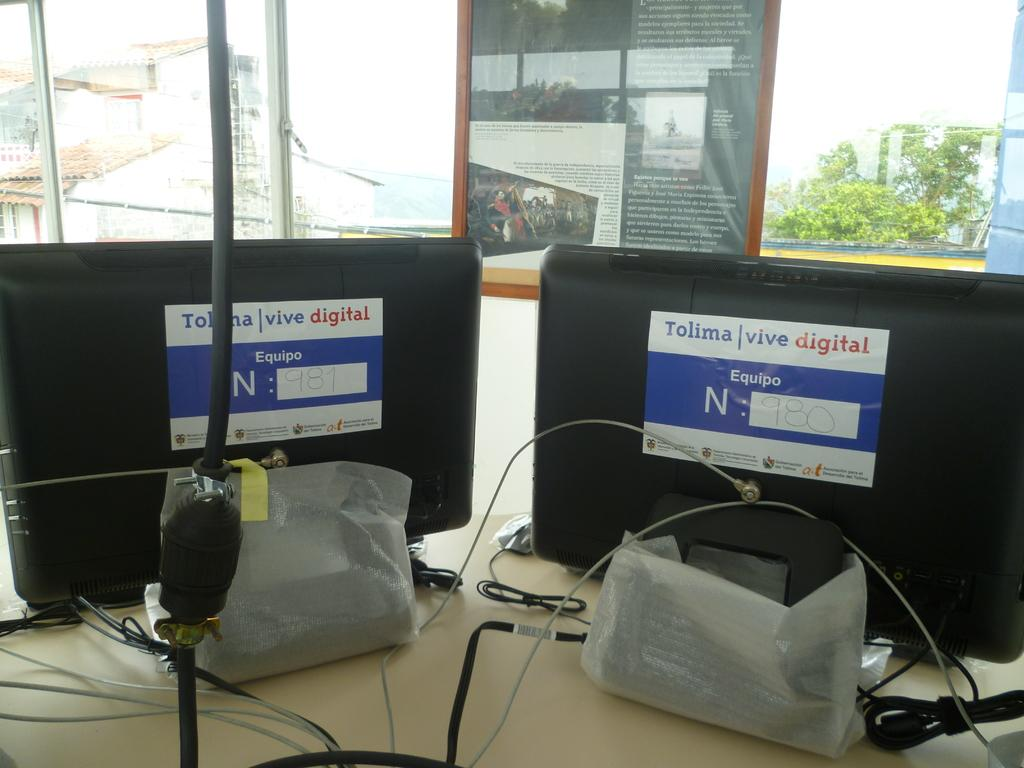Provide a one-sentence caption for the provided image. Two computers with Tolima Vive digital stickers on them. 